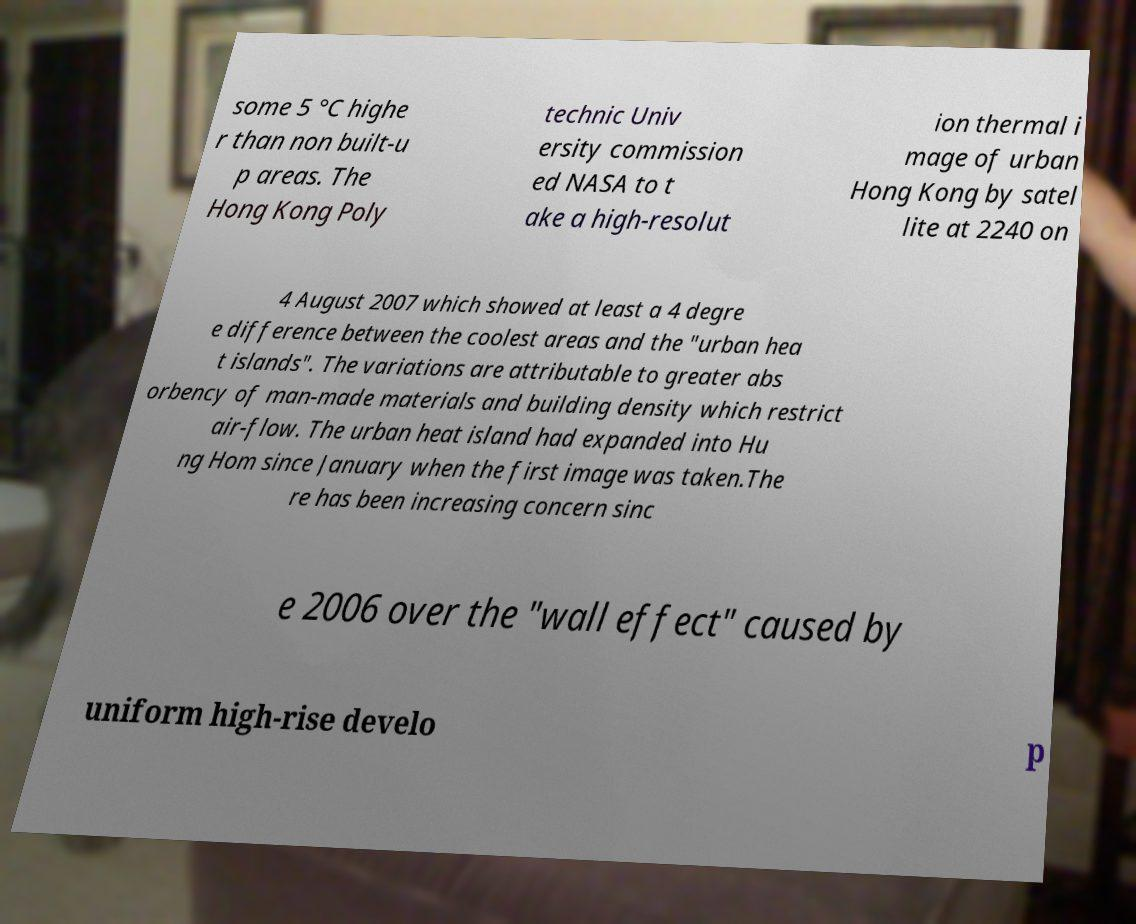What messages or text are displayed in this image? I need them in a readable, typed format. some 5 °C highe r than non built-u p areas. The Hong Kong Poly technic Univ ersity commission ed NASA to t ake a high-resolut ion thermal i mage of urban Hong Kong by satel lite at 2240 on 4 August 2007 which showed at least a 4 degre e difference between the coolest areas and the "urban hea t islands". The variations are attributable to greater abs orbency of man-made materials and building density which restrict air-flow. The urban heat island had expanded into Hu ng Hom since January when the first image was taken.The re has been increasing concern sinc e 2006 over the "wall effect" caused by uniform high-rise develo p 